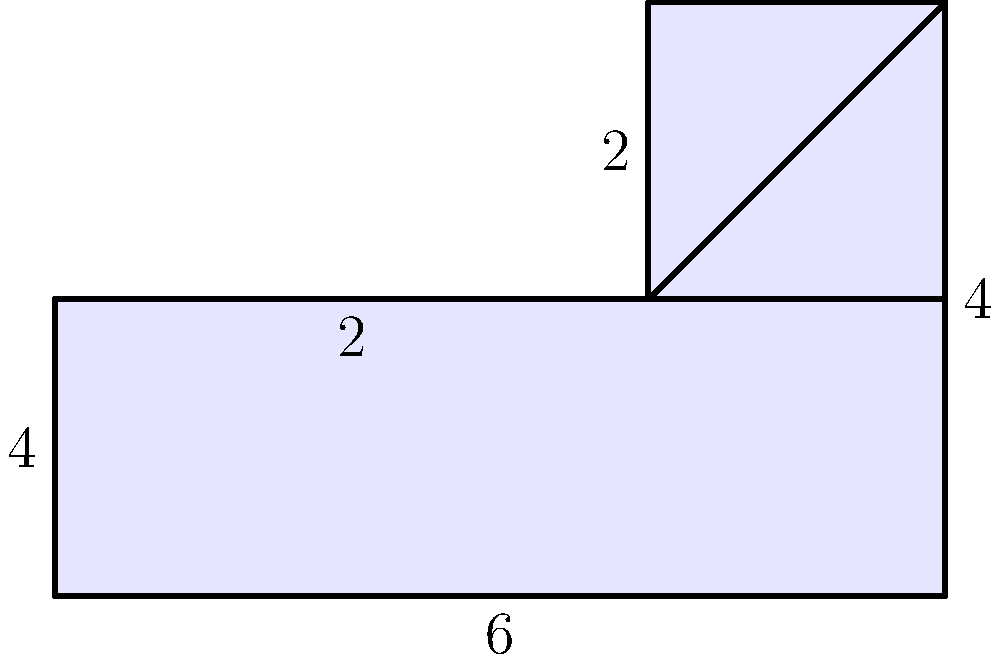In a property dispute case, you are presented with a plot of land shaped as shown in the figure above. The dimensions are given in meters. Calculate the total area of the plot to determine its value for legal proceedings. To calculate the total area, we'll divide the shape into simpler geometric forms and sum their areas:

1. Main rectangle:
   Length = 6 m, Width = 2 m
   Area = $6 \times 2 = 12$ m²

2. Smaller rectangle:
   Length = 4 m, Width = 2 m
   Area = $4 \times 2 = 8$ m²

3. Triangle:
   Base = 2 m, Height = 2 m
   Area = $\frac{1}{2} \times 2 \times 2 = 2$ m²

Total Area = Main rectangle + Smaller rectangle + Triangle
           = $12 + 8 + 2 = 22$ m²

Therefore, the total area of the plot is 22 square meters.
Answer: 22 m² 